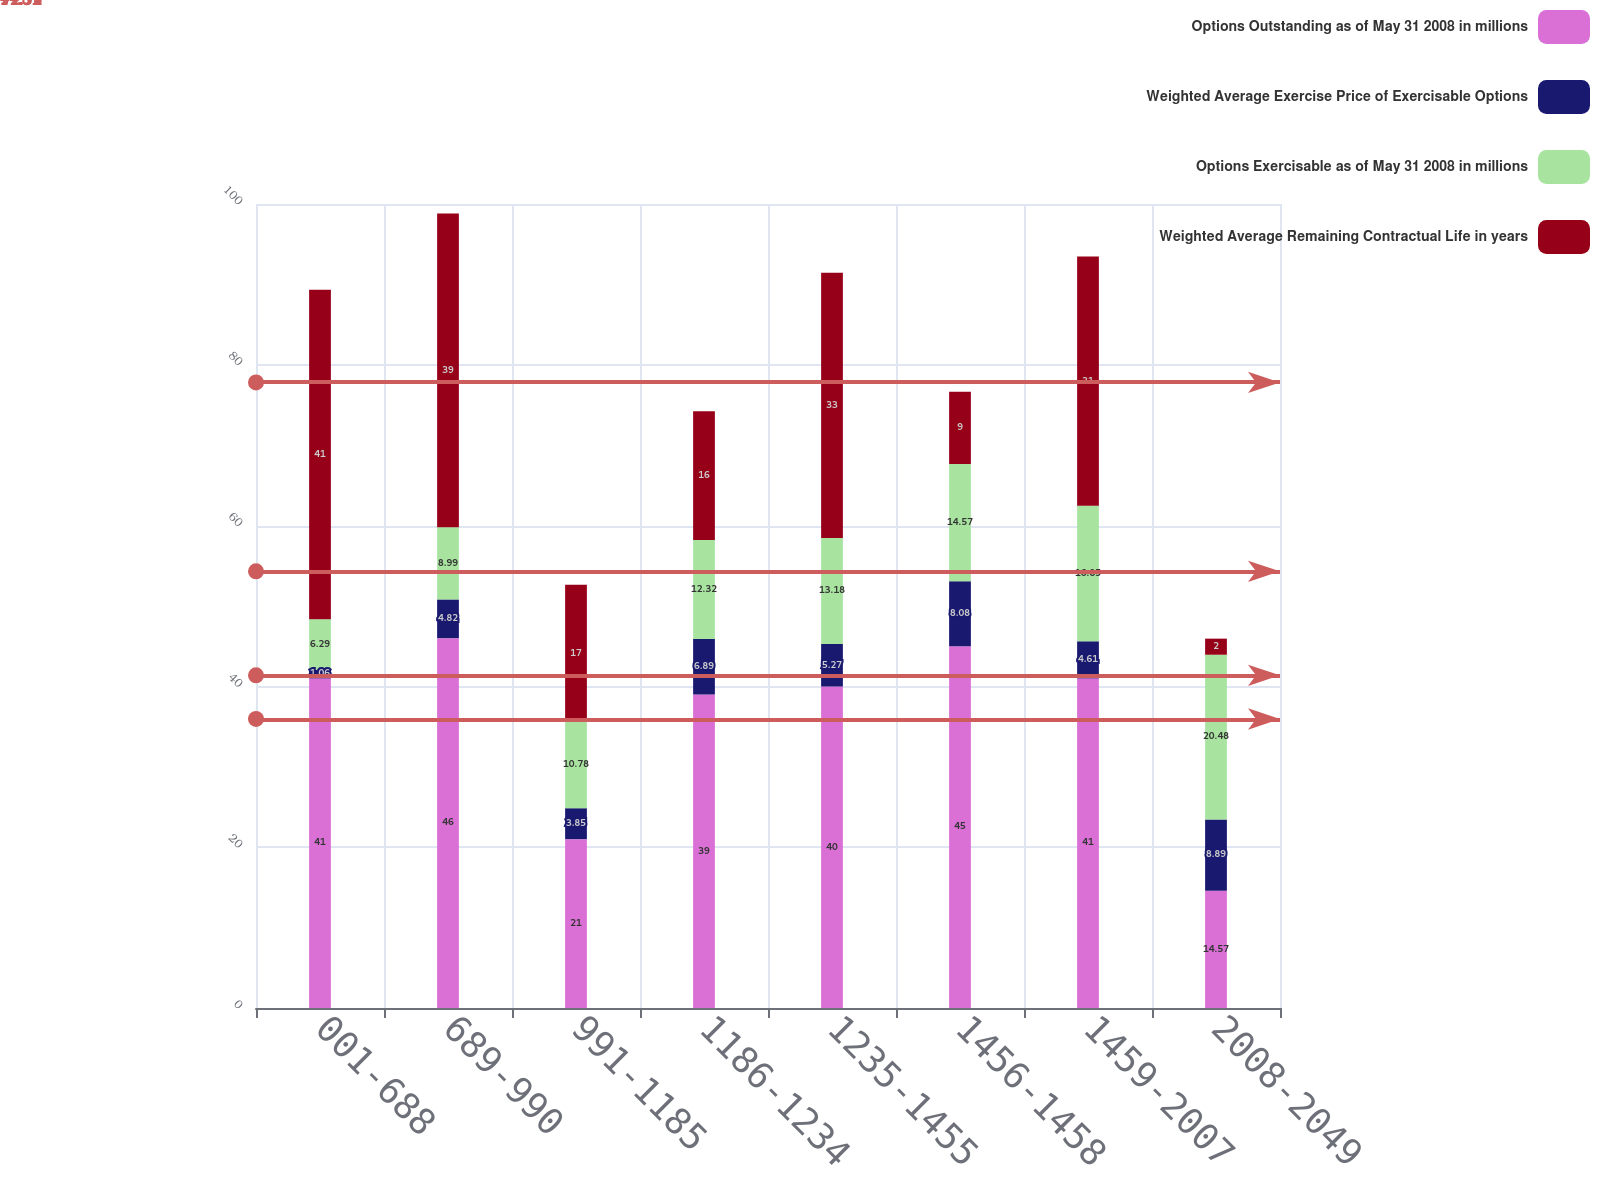Convert chart. <chart><loc_0><loc_0><loc_500><loc_500><stacked_bar_chart><ecel><fcel>001-688<fcel>689-990<fcel>991-1185<fcel>1186-1234<fcel>1235-1455<fcel>1456-1458<fcel>1459-2007<fcel>2008-2049<nl><fcel>Options Outstanding as of May 31 2008 in millions<fcel>41<fcel>46<fcel>21<fcel>39<fcel>40<fcel>45<fcel>41<fcel>14.57<nl><fcel>Weighted Average Exercise Price of Exercisable Options<fcel>1.06<fcel>4.82<fcel>3.85<fcel>6.89<fcel>5.27<fcel>8.08<fcel>4.61<fcel>8.89<nl><fcel>Options Exercisable as of May 31 2008 in millions<fcel>6.29<fcel>8.99<fcel>10.78<fcel>12.32<fcel>13.18<fcel>14.57<fcel>16.85<fcel>20.48<nl><fcel>Weighted Average Remaining Contractual Life in years<fcel>41<fcel>39<fcel>17<fcel>16<fcel>33<fcel>9<fcel>31<fcel>2<nl></chart> 